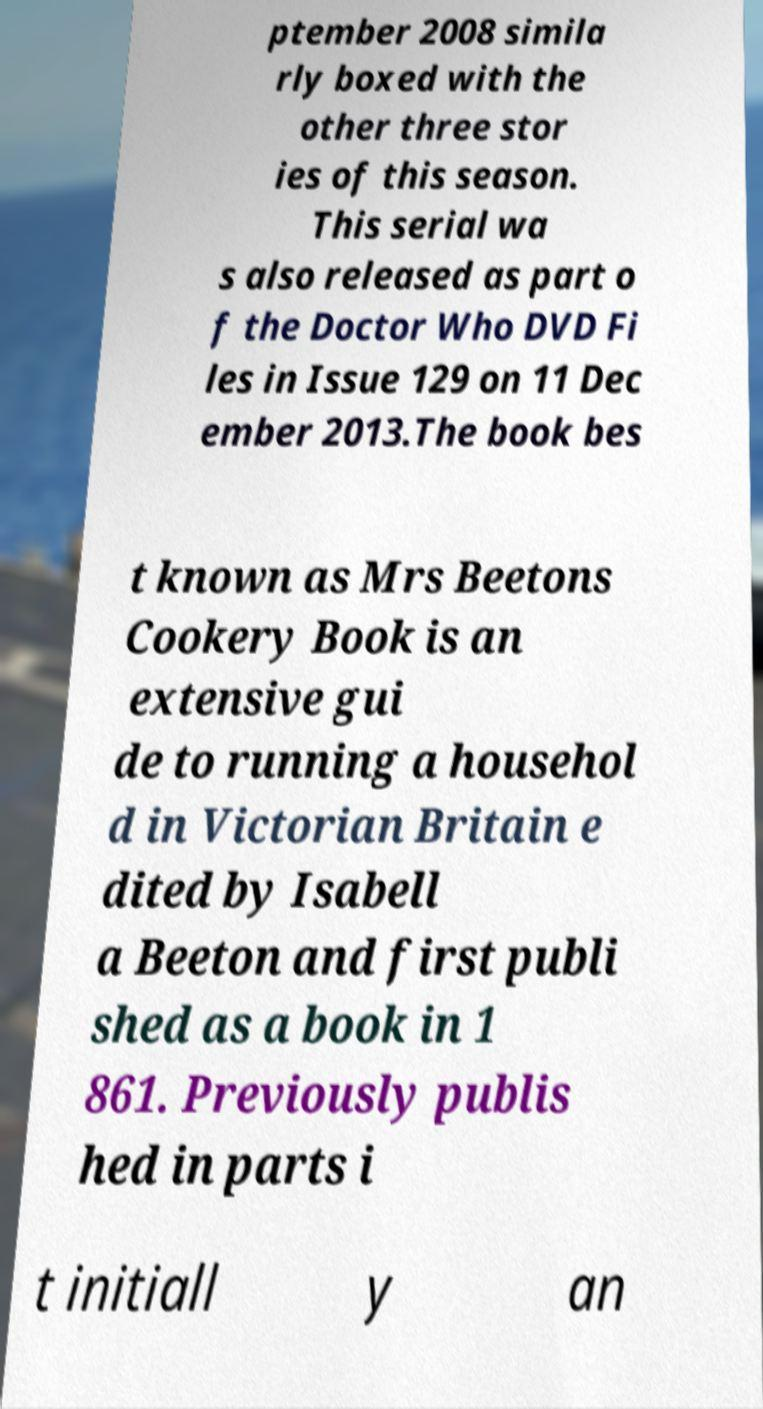Can you read and provide the text displayed in the image?This photo seems to have some interesting text. Can you extract and type it out for me? ptember 2008 simila rly boxed with the other three stor ies of this season. This serial wa s also released as part o f the Doctor Who DVD Fi les in Issue 129 on 11 Dec ember 2013.The book bes t known as Mrs Beetons Cookery Book is an extensive gui de to running a househol d in Victorian Britain e dited by Isabell a Beeton and first publi shed as a book in 1 861. Previously publis hed in parts i t initiall y an 